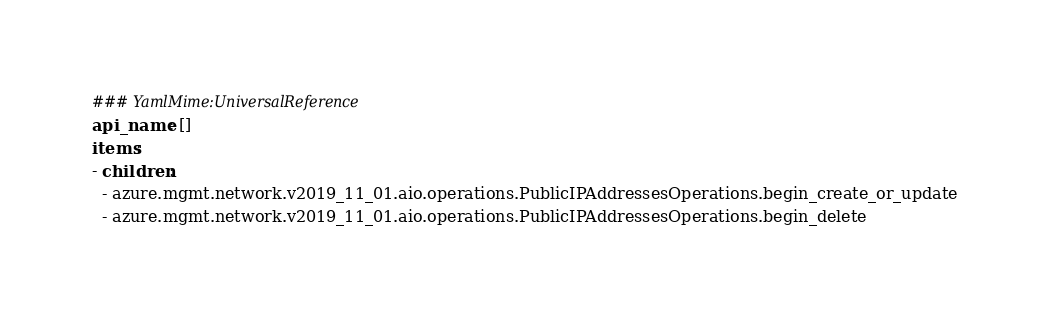<code> <loc_0><loc_0><loc_500><loc_500><_YAML_>### YamlMime:UniversalReference
api_name: []
items:
- children:
  - azure.mgmt.network.v2019_11_01.aio.operations.PublicIPAddressesOperations.begin_create_or_update
  - azure.mgmt.network.v2019_11_01.aio.operations.PublicIPAddressesOperations.begin_delete</code> 